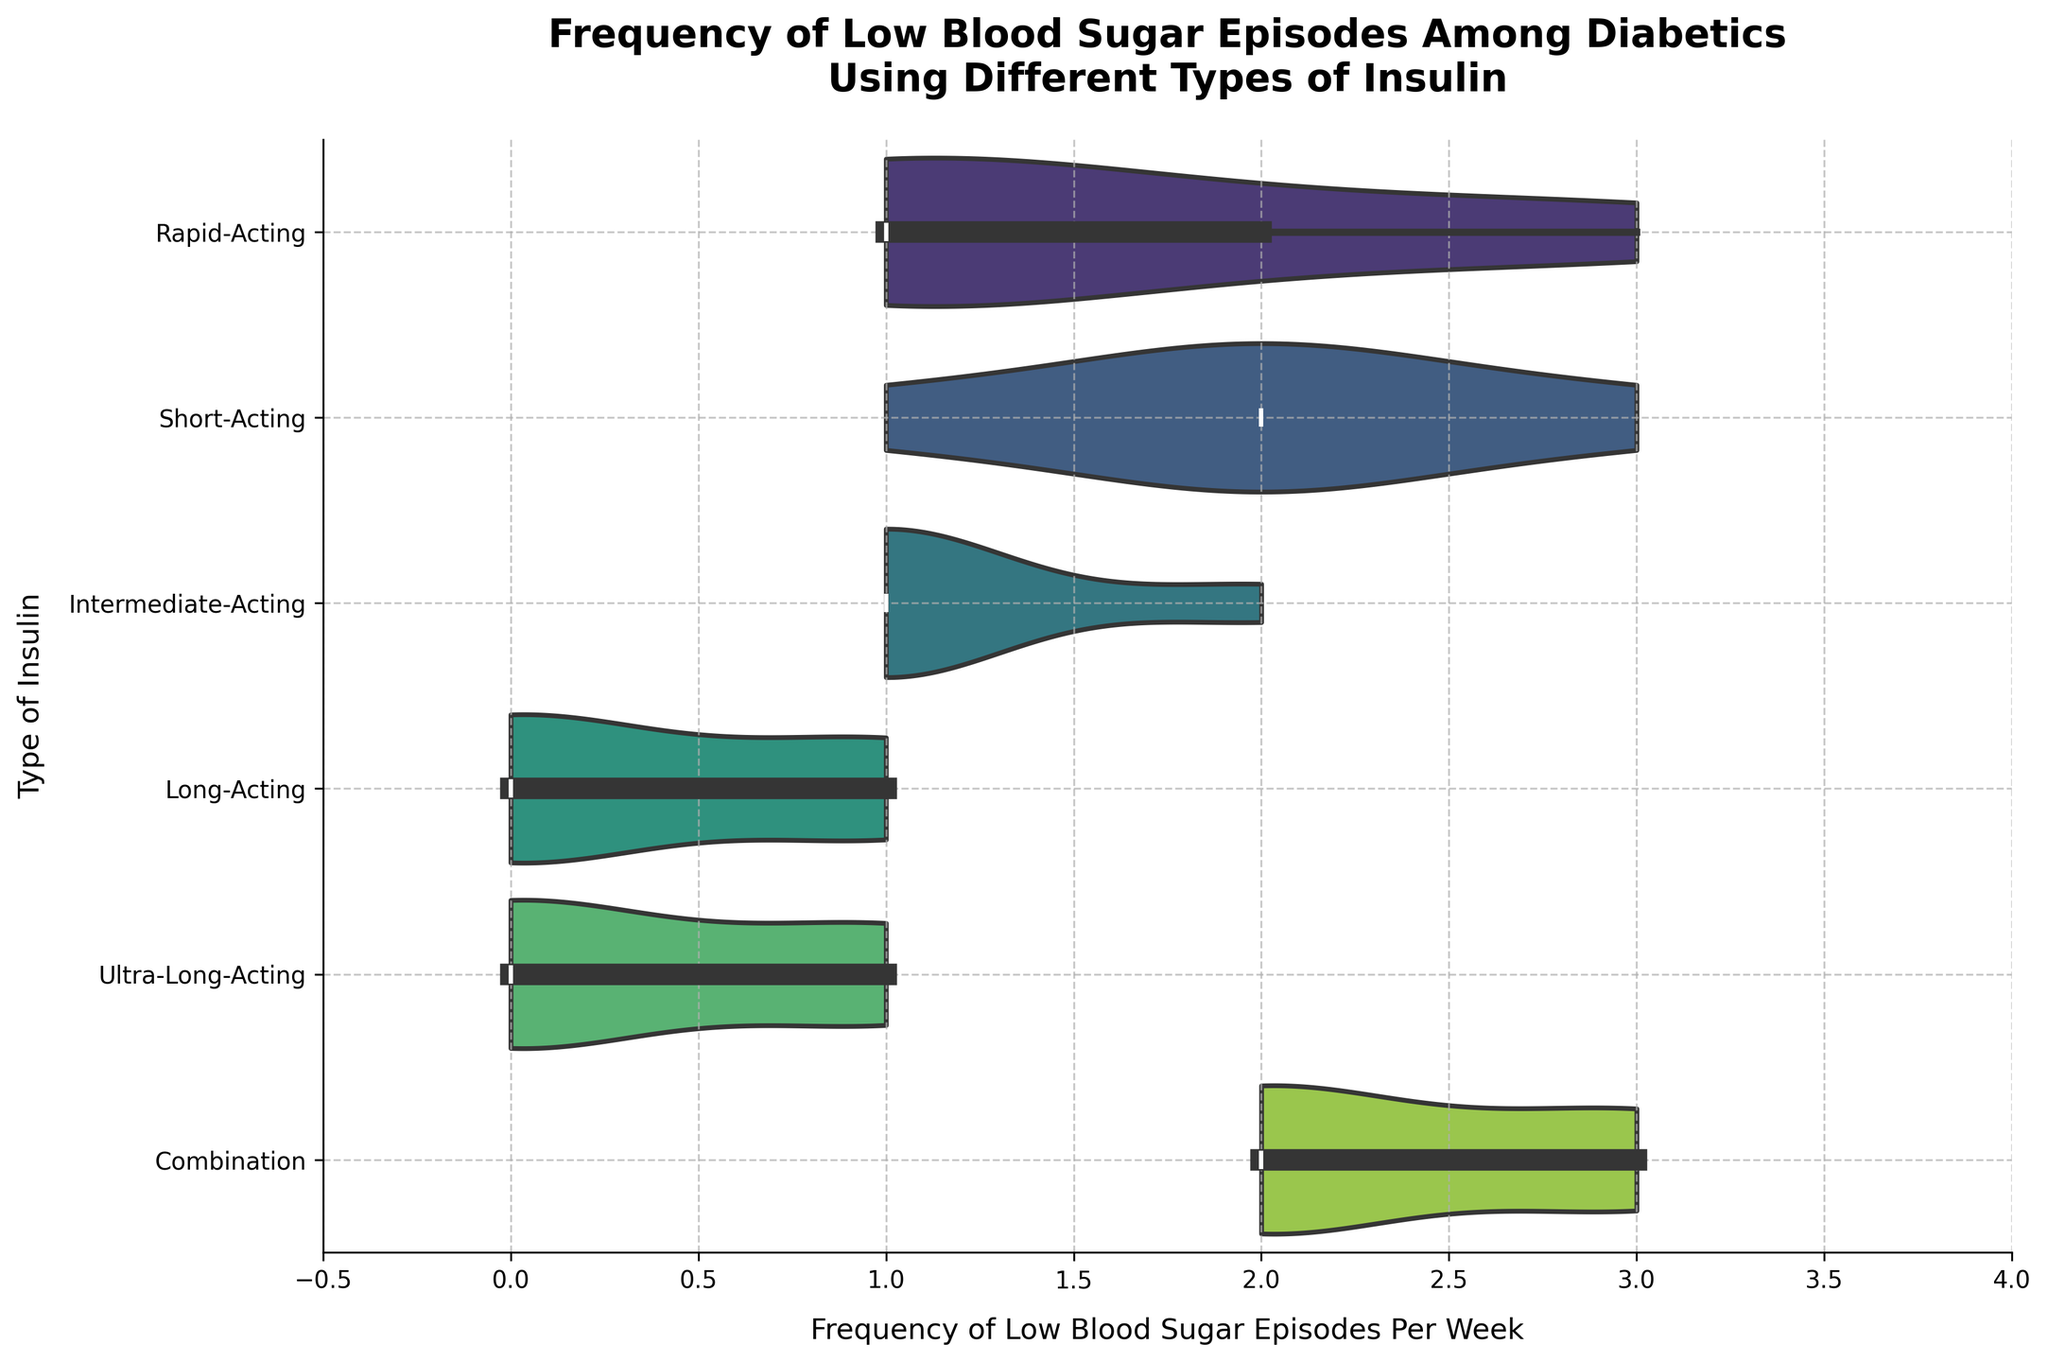What is the title of the figure? The title of the figure is displayed at the top and provides an overview of what the figure is about. For this plot, the title is "Frequency of Low Blood Sugar Episodes Among Diabetics Using Different Types of Insulin".
Answer: Frequency of Low Blood Sugar Episodes Among Diabetics Using Different Types of Insulin What is the most frequent number of low blood sugar episodes for people using Long-Acting insulin? Look at the density and the box plot within the violin plot for Long-Acting insulin to determine which episode frequency has the highest density.
Answer: 0 Which type of insulin shows the widest range of low blood sugar episode frequencies? Examine the horizontal spread of each violin plot. The widest horizontal spread indicates the widest range of frequencies. Combination insulin shows frequencies ranging from 2 to 3.
Answer: Combination Which type of insulin has the lowest median frequency of low blood sugar episodes? The median is indicated by the horizontal line within each violin plot. Look for the violin plot with the lowest position of this line. Ultra-Long-Acting and Long-Acting insulin both have a median of 0.
Answer: Long-Acting, Ultra-Long-Acting What is the range of low blood sugar episodes for Short-Acting insulin users? The range is determined by looking at the spread of the violin plot for Short-Acting insulin. It spans from 1 to 3 episodes per week.
Answer: 1 to 3 For which insulin type(s) is the median frequency equal to 1? Identify the insulin types where the median value (the thick line inside the violin plot) is at 1. Rapid-Acting, Short-Acting, Intermediate-Acting, Long-Acting, and Ultra-Long-Acting all meet this criterion.
Answer: Rapid-Acting, Short-Acting, Intermediate-Acting, Long-Acting, Ultra-Long-Acting Which insulin type exhibits the highest variability in low blood sugar episodes? Variability is indicated by the spread of the data within the violin plot. A wider and more spread out plot indicates higher variability. Combination insulin shows this trait.
Answer: Combination Which insulin types have the lowest frequency of zero low blood sugar episodes? Zero low blood sugar episodes are shown at the leftmost end of each violin plot. Ultra-Long-Acting and Long-Acting insulin types have the highest density at zero.
Answer: Intermediate-Acting, Rapid-Acting, Short-Acting, Combination 